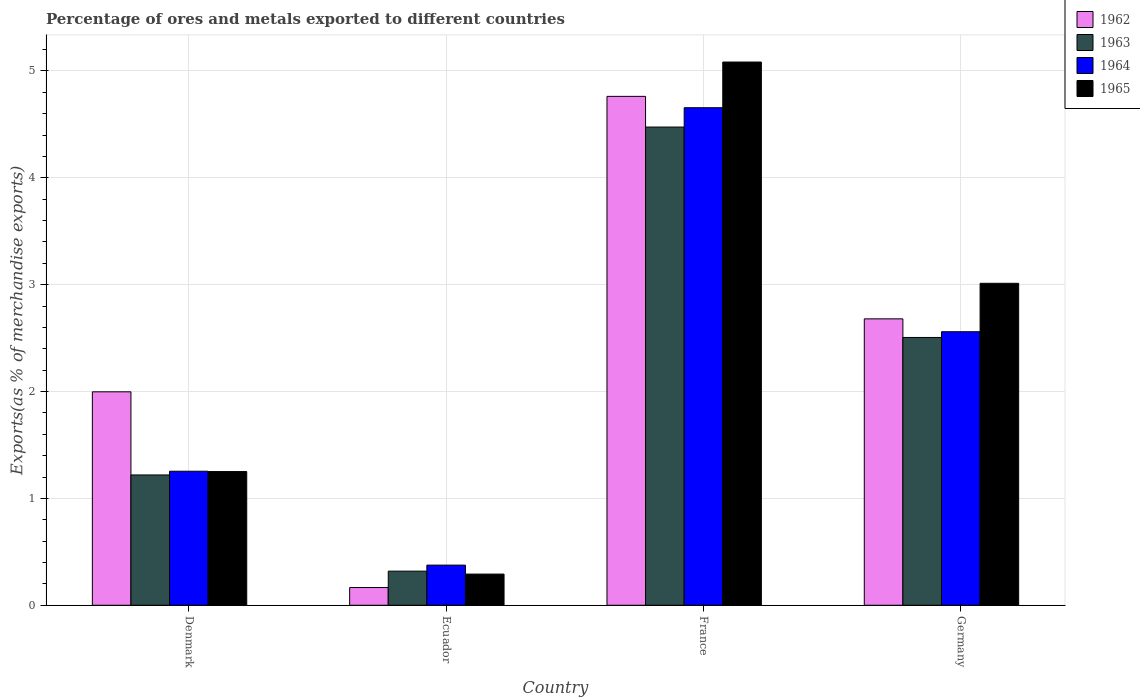Are the number of bars on each tick of the X-axis equal?
Ensure brevity in your answer.  Yes. How many bars are there on the 4th tick from the left?
Offer a very short reply. 4. How many bars are there on the 3rd tick from the right?
Your answer should be compact. 4. What is the label of the 2nd group of bars from the left?
Provide a succinct answer. Ecuador. In how many cases, is the number of bars for a given country not equal to the number of legend labels?
Provide a succinct answer. 0. What is the percentage of exports to different countries in 1963 in Germany?
Your response must be concise. 2.51. Across all countries, what is the maximum percentage of exports to different countries in 1964?
Offer a terse response. 4.66. Across all countries, what is the minimum percentage of exports to different countries in 1962?
Your response must be concise. 0.17. In which country was the percentage of exports to different countries in 1965 minimum?
Offer a terse response. Ecuador. What is the total percentage of exports to different countries in 1965 in the graph?
Offer a terse response. 9.64. What is the difference between the percentage of exports to different countries in 1963 in Denmark and that in Germany?
Your answer should be compact. -1.29. What is the difference between the percentage of exports to different countries in 1965 in Germany and the percentage of exports to different countries in 1963 in France?
Your answer should be very brief. -1.46. What is the average percentage of exports to different countries in 1962 per country?
Your answer should be very brief. 2.4. What is the difference between the percentage of exports to different countries of/in 1963 and percentage of exports to different countries of/in 1964 in Ecuador?
Make the answer very short. -0.06. In how many countries, is the percentage of exports to different countries in 1964 greater than 3.2 %?
Offer a very short reply. 1. What is the ratio of the percentage of exports to different countries in 1965 in Denmark to that in Germany?
Offer a very short reply. 0.42. Is the difference between the percentage of exports to different countries in 1963 in Denmark and Germany greater than the difference between the percentage of exports to different countries in 1964 in Denmark and Germany?
Ensure brevity in your answer.  Yes. What is the difference between the highest and the second highest percentage of exports to different countries in 1962?
Provide a succinct answer. -0.68. What is the difference between the highest and the lowest percentage of exports to different countries in 1963?
Your answer should be compact. 4.16. Is the sum of the percentage of exports to different countries in 1965 in Ecuador and France greater than the maximum percentage of exports to different countries in 1963 across all countries?
Ensure brevity in your answer.  Yes. Is it the case that in every country, the sum of the percentage of exports to different countries in 1963 and percentage of exports to different countries in 1965 is greater than the sum of percentage of exports to different countries in 1964 and percentage of exports to different countries in 1962?
Provide a short and direct response. No. What does the 3rd bar from the left in Germany represents?
Your response must be concise. 1964. What does the 1st bar from the right in France represents?
Your answer should be very brief. 1965. Is it the case that in every country, the sum of the percentage of exports to different countries in 1962 and percentage of exports to different countries in 1965 is greater than the percentage of exports to different countries in 1963?
Give a very brief answer. Yes. Does the graph contain any zero values?
Your response must be concise. No. Does the graph contain grids?
Your response must be concise. Yes. Where does the legend appear in the graph?
Provide a succinct answer. Top right. How many legend labels are there?
Make the answer very short. 4. How are the legend labels stacked?
Ensure brevity in your answer.  Vertical. What is the title of the graph?
Offer a very short reply. Percentage of ores and metals exported to different countries. What is the label or title of the Y-axis?
Your answer should be compact. Exports(as % of merchandise exports). What is the Exports(as % of merchandise exports) of 1962 in Denmark?
Your response must be concise. 2. What is the Exports(as % of merchandise exports) of 1963 in Denmark?
Make the answer very short. 1.22. What is the Exports(as % of merchandise exports) in 1964 in Denmark?
Provide a succinct answer. 1.25. What is the Exports(as % of merchandise exports) of 1965 in Denmark?
Your answer should be very brief. 1.25. What is the Exports(as % of merchandise exports) of 1962 in Ecuador?
Your answer should be compact. 0.17. What is the Exports(as % of merchandise exports) in 1963 in Ecuador?
Your response must be concise. 0.32. What is the Exports(as % of merchandise exports) of 1964 in Ecuador?
Give a very brief answer. 0.38. What is the Exports(as % of merchandise exports) of 1965 in Ecuador?
Your answer should be very brief. 0.29. What is the Exports(as % of merchandise exports) of 1962 in France?
Provide a succinct answer. 4.76. What is the Exports(as % of merchandise exports) in 1963 in France?
Keep it short and to the point. 4.48. What is the Exports(as % of merchandise exports) in 1964 in France?
Your answer should be compact. 4.66. What is the Exports(as % of merchandise exports) of 1965 in France?
Ensure brevity in your answer.  5.08. What is the Exports(as % of merchandise exports) in 1962 in Germany?
Your answer should be very brief. 2.68. What is the Exports(as % of merchandise exports) in 1963 in Germany?
Ensure brevity in your answer.  2.51. What is the Exports(as % of merchandise exports) of 1964 in Germany?
Give a very brief answer. 2.56. What is the Exports(as % of merchandise exports) of 1965 in Germany?
Keep it short and to the point. 3.01. Across all countries, what is the maximum Exports(as % of merchandise exports) in 1962?
Offer a very short reply. 4.76. Across all countries, what is the maximum Exports(as % of merchandise exports) in 1963?
Your answer should be compact. 4.48. Across all countries, what is the maximum Exports(as % of merchandise exports) of 1964?
Your response must be concise. 4.66. Across all countries, what is the maximum Exports(as % of merchandise exports) of 1965?
Give a very brief answer. 5.08. Across all countries, what is the minimum Exports(as % of merchandise exports) in 1962?
Offer a terse response. 0.17. Across all countries, what is the minimum Exports(as % of merchandise exports) of 1963?
Provide a succinct answer. 0.32. Across all countries, what is the minimum Exports(as % of merchandise exports) of 1964?
Keep it short and to the point. 0.38. Across all countries, what is the minimum Exports(as % of merchandise exports) in 1965?
Ensure brevity in your answer.  0.29. What is the total Exports(as % of merchandise exports) of 1962 in the graph?
Make the answer very short. 9.61. What is the total Exports(as % of merchandise exports) in 1963 in the graph?
Ensure brevity in your answer.  8.52. What is the total Exports(as % of merchandise exports) in 1964 in the graph?
Keep it short and to the point. 8.85. What is the total Exports(as % of merchandise exports) in 1965 in the graph?
Your answer should be compact. 9.64. What is the difference between the Exports(as % of merchandise exports) of 1962 in Denmark and that in Ecuador?
Offer a very short reply. 1.83. What is the difference between the Exports(as % of merchandise exports) of 1963 in Denmark and that in Ecuador?
Your answer should be compact. 0.9. What is the difference between the Exports(as % of merchandise exports) of 1964 in Denmark and that in Ecuador?
Your response must be concise. 0.88. What is the difference between the Exports(as % of merchandise exports) in 1965 in Denmark and that in Ecuador?
Give a very brief answer. 0.96. What is the difference between the Exports(as % of merchandise exports) in 1962 in Denmark and that in France?
Make the answer very short. -2.76. What is the difference between the Exports(as % of merchandise exports) of 1963 in Denmark and that in France?
Your answer should be compact. -3.26. What is the difference between the Exports(as % of merchandise exports) in 1964 in Denmark and that in France?
Offer a very short reply. -3.4. What is the difference between the Exports(as % of merchandise exports) in 1965 in Denmark and that in France?
Your answer should be compact. -3.83. What is the difference between the Exports(as % of merchandise exports) of 1962 in Denmark and that in Germany?
Your answer should be compact. -0.68. What is the difference between the Exports(as % of merchandise exports) of 1963 in Denmark and that in Germany?
Provide a succinct answer. -1.29. What is the difference between the Exports(as % of merchandise exports) in 1964 in Denmark and that in Germany?
Your response must be concise. -1.31. What is the difference between the Exports(as % of merchandise exports) in 1965 in Denmark and that in Germany?
Offer a very short reply. -1.76. What is the difference between the Exports(as % of merchandise exports) in 1962 in Ecuador and that in France?
Make the answer very short. -4.6. What is the difference between the Exports(as % of merchandise exports) in 1963 in Ecuador and that in France?
Keep it short and to the point. -4.16. What is the difference between the Exports(as % of merchandise exports) of 1964 in Ecuador and that in France?
Provide a short and direct response. -4.28. What is the difference between the Exports(as % of merchandise exports) of 1965 in Ecuador and that in France?
Provide a succinct answer. -4.79. What is the difference between the Exports(as % of merchandise exports) of 1962 in Ecuador and that in Germany?
Offer a very short reply. -2.51. What is the difference between the Exports(as % of merchandise exports) of 1963 in Ecuador and that in Germany?
Provide a succinct answer. -2.19. What is the difference between the Exports(as % of merchandise exports) in 1964 in Ecuador and that in Germany?
Your answer should be very brief. -2.18. What is the difference between the Exports(as % of merchandise exports) of 1965 in Ecuador and that in Germany?
Offer a very short reply. -2.72. What is the difference between the Exports(as % of merchandise exports) of 1962 in France and that in Germany?
Your answer should be compact. 2.08. What is the difference between the Exports(as % of merchandise exports) in 1963 in France and that in Germany?
Your response must be concise. 1.97. What is the difference between the Exports(as % of merchandise exports) in 1964 in France and that in Germany?
Your response must be concise. 2.1. What is the difference between the Exports(as % of merchandise exports) in 1965 in France and that in Germany?
Your response must be concise. 2.07. What is the difference between the Exports(as % of merchandise exports) in 1962 in Denmark and the Exports(as % of merchandise exports) in 1963 in Ecuador?
Offer a terse response. 1.68. What is the difference between the Exports(as % of merchandise exports) of 1962 in Denmark and the Exports(as % of merchandise exports) of 1964 in Ecuador?
Your response must be concise. 1.62. What is the difference between the Exports(as % of merchandise exports) in 1962 in Denmark and the Exports(as % of merchandise exports) in 1965 in Ecuador?
Your response must be concise. 1.71. What is the difference between the Exports(as % of merchandise exports) of 1963 in Denmark and the Exports(as % of merchandise exports) of 1964 in Ecuador?
Provide a short and direct response. 0.84. What is the difference between the Exports(as % of merchandise exports) of 1963 in Denmark and the Exports(as % of merchandise exports) of 1965 in Ecuador?
Keep it short and to the point. 0.93. What is the difference between the Exports(as % of merchandise exports) in 1964 in Denmark and the Exports(as % of merchandise exports) in 1965 in Ecuador?
Provide a short and direct response. 0.96. What is the difference between the Exports(as % of merchandise exports) in 1962 in Denmark and the Exports(as % of merchandise exports) in 1963 in France?
Keep it short and to the point. -2.48. What is the difference between the Exports(as % of merchandise exports) in 1962 in Denmark and the Exports(as % of merchandise exports) in 1964 in France?
Ensure brevity in your answer.  -2.66. What is the difference between the Exports(as % of merchandise exports) in 1962 in Denmark and the Exports(as % of merchandise exports) in 1965 in France?
Offer a terse response. -3.09. What is the difference between the Exports(as % of merchandise exports) of 1963 in Denmark and the Exports(as % of merchandise exports) of 1964 in France?
Give a very brief answer. -3.44. What is the difference between the Exports(as % of merchandise exports) in 1963 in Denmark and the Exports(as % of merchandise exports) in 1965 in France?
Keep it short and to the point. -3.86. What is the difference between the Exports(as % of merchandise exports) of 1964 in Denmark and the Exports(as % of merchandise exports) of 1965 in France?
Give a very brief answer. -3.83. What is the difference between the Exports(as % of merchandise exports) of 1962 in Denmark and the Exports(as % of merchandise exports) of 1963 in Germany?
Ensure brevity in your answer.  -0.51. What is the difference between the Exports(as % of merchandise exports) of 1962 in Denmark and the Exports(as % of merchandise exports) of 1964 in Germany?
Keep it short and to the point. -0.56. What is the difference between the Exports(as % of merchandise exports) in 1962 in Denmark and the Exports(as % of merchandise exports) in 1965 in Germany?
Provide a succinct answer. -1.02. What is the difference between the Exports(as % of merchandise exports) of 1963 in Denmark and the Exports(as % of merchandise exports) of 1964 in Germany?
Offer a terse response. -1.34. What is the difference between the Exports(as % of merchandise exports) of 1963 in Denmark and the Exports(as % of merchandise exports) of 1965 in Germany?
Offer a terse response. -1.79. What is the difference between the Exports(as % of merchandise exports) of 1964 in Denmark and the Exports(as % of merchandise exports) of 1965 in Germany?
Keep it short and to the point. -1.76. What is the difference between the Exports(as % of merchandise exports) of 1962 in Ecuador and the Exports(as % of merchandise exports) of 1963 in France?
Provide a short and direct response. -4.31. What is the difference between the Exports(as % of merchandise exports) in 1962 in Ecuador and the Exports(as % of merchandise exports) in 1964 in France?
Offer a very short reply. -4.49. What is the difference between the Exports(as % of merchandise exports) of 1962 in Ecuador and the Exports(as % of merchandise exports) of 1965 in France?
Your answer should be very brief. -4.92. What is the difference between the Exports(as % of merchandise exports) of 1963 in Ecuador and the Exports(as % of merchandise exports) of 1964 in France?
Make the answer very short. -4.34. What is the difference between the Exports(as % of merchandise exports) of 1963 in Ecuador and the Exports(as % of merchandise exports) of 1965 in France?
Your response must be concise. -4.76. What is the difference between the Exports(as % of merchandise exports) of 1964 in Ecuador and the Exports(as % of merchandise exports) of 1965 in France?
Give a very brief answer. -4.71. What is the difference between the Exports(as % of merchandise exports) in 1962 in Ecuador and the Exports(as % of merchandise exports) in 1963 in Germany?
Offer a terse response. -2.34. What is the difference between the Exports(as % of merchandise exports) of 1962 in Ecuador and the Exports(as % of merchandise exports) of 1964 in Germany?
Your response must be concise. -2.39. What is the difference between the Exports(as % of merchandise exports) of 1962 in Ecuador and the Exports(as % of merchandise exports) of 1965 in Germany?
Keep it short and to the point. -2.85. What is the difference between the Exports(as % of merchandise exports) in 1963 in Ecuador and the Exports(as % of merchandise exports) in 1964 in Germany?
Offer a very short reply. -2.24. What is the difference between the Exports(as % of merchandise exports) in 1963 in Ecuador and the Exports(as % of merchandise exports) in 1965 in Germany?
Offer a terse response. -2.69. What is the difference between the Exports(as % of merchandise exports) of 1964 in Ecuador and the Exports(as % of merchandise exports) of 1965 in Germany?
Keep it short and to the point. -2.64. What is the difference between the Exports(as % of merchandise exports) in 1962 in France and the Exports(as % of merchandise exports) in 1963 in Germany?
Give a very brief answer. 2.26. What is the difference between the Exports(as % of merchandise exports) of 1962 in France and the Exports(as % of merchandise exports) of 1964 in Germany?
Ensure brevity in your answer.  2.2. What is the difference between the Exports(as % of merchandise exports) of 1962 in France and the Exports(as % of merchandise exports) of 1965 in Germany?
Offer a terse response. 1.75. What is the difference between the Exports(as % of merchandise exports) in 1963 in France and the Exports(as % of merchandise exports) in 1964 in Germany?
Offer a terse response. 1.92. What is the difference between the Exports(as % of merchandise exports) in 1963 in France and the Exports(as % of merchandise exports) in 1965 in Germany?
Your response must be concise. 1.46. What is the difference between the Exports(as % of merchandise exports) of 1964 in France and the Exports(as % of merchandise exports) of 1965 in Germany?
Your answer should be very brief. 1.64. What is the average Exports(as % of merchandise exports) of 1962 per country?
Keep it short and to the point. 2.4. What is the average Exports(as % of merchandise exports) of 1963 per country?
Ensure brevity in your answer.  2.13. What is the average Exports(as % of merchandise exports) in 1964 per country?
Offer a terse response. 2.21. What is the average Exports(as % of merchandise exports) of 1965 per country?
Make the answer very short. 2.41. What is the difference between the Exports(as % of merchandise exports) in 1962 and Exports(as % of merchandise exports) in 1963 in Denmark?
Your answer should be very brief. 0.78. What is the difference between the Exports(as % of merchandise exports) in 1962 and Exports(as % of merchandise exports) in 1964 in Denmark?
Keep it short and to the point. 0.74. What is the difference between the Exports(as % of merchandise exports) in 1962 and Exports(as % of merchandise exports) in 1965 in Denmark?
Ensure brevity in your answer.  0.75. What is the difference between the Exports(as % of merchandise exports) in 1963 and Exports(as % of merchandise exports) in 1964 in Denmark?
Offer a very short reply. -0.03. What is the difference between the Exports(as % of merchandise exports) in 1963 and Exports(as % of merchandise exports) in 1965 in Denmark?
Ensure brevity in your answer.  -0.03. What is the difference between the Exports(as % of merchandise exports) of 1964 and Exports(as % of merchandise exports) of 1965 in Denmark?
Your answer should be compact. 0. What is the difference between the Exports(as % of merchandise exports) of 1962 and Exports(as % of merchandise exports) of 1963 in Ecuador?
Your answer should be very brief. -0.15. What is the difference between the Exports(as % of merchandise exports) of 1962 and Exports(as % of merchandise exports) of 1964 in Ecuador?
Provide a succinct answer. -0.21. What is the difference between the Exports(as % of merchandise exports) in 1962 and Exports(as % of merchandise exports) in 1965 in Ecuador?
Ensure brevity in your answer.  -0.13. What is the difference between the Exports(as % of merchandise exports) in 1963 and Exports(as % of merchandise exports) in 1964 in Ecuador?
Ensure brevity in your answer.  -0.06. What is the difference between the Exports(as % of merchandise exports) of 1963 and Exports(as % of merchandise exports) of 1965 in Ecuador?
Make the answer very short. 0.03. What is the difference between the Exports(as % of merchandise exports) of 1964 and Exports(as % of merchandise exports) of 1965 in Ecuador?
Make the answer very short. 0.08. What is the difference between the Exports(as % of merchandise exports) in 1962 and Exports(as % of merchandise exports) in 1963 in France?
Keep it short and to the point. 0.29. What is the difference between the Exports(as % of merchandise exports) of 1962 and Exports(as % of merchandise exports) of 1964 in France?
Your answer should be very brief. 0.11. What is the difference between the Exports(as % of merchandise exports) in 1962 and Exports(as % of merchandise exports) in 1965 in France?
Offer a very short reply. -0.32. What is the difference between the Exports(as % of merchandise exports) of 1963 and Exports(as % of merchandise exports) of 1964 in France?
Provide a succinct answer. -0.18. What is the difference between the Exports(as % of merchandise exports) of 1963 and Exports(as % of merchandise exports) of 1965 in France?
Provide a short and direct response. -0.61. What is the difference between the Exports(as % of merchandise exports) of 1964 and Exports(as % of merchandise exports) of 1965 in France?
Keep it short and to the point. -0.43. What is the difference between the Exports(as % of merchandise exports) of 1962 and Exports(as % of merchandise exports) of 1963 in Germany?
Give a very brief answer. 0.17. What is the difference between the Exports(as % of merchandise exports) of 1962 and Exports(as % of merchandise exports) of 1964 in Germany?
Your response must be concise. 0.12. What is the difference between the Exports(as % of merchandise exports) of 1962 and Exports(as % of merchandise exports) of 1965 in Germany?
Provide a succinct answer. -0.33. What is the difference between the Exports(as % of merchandise exports) in 1963 and Exports(as % of merchandise exports) in 1964 in Germany?
Make the answer very short. -0.05. What is the difference between the Exports(as % of merchandise exports) of 1963 and Exports(as % of merchandise exports) of 1965 in Germany?
Keep it short and to the point. -0.51. What is the difference between the Exports(as % of merchandise exports) of 1964 and Exports(as % of merchandise exports) of 1965 in Germany?
Offer a terse response. -0.45. What is the ratio of the Exports(as % of merchandise exports) in 1962 in Denmark to that in Ecuador?
Keep it short and to the point. 12.05. What is the ratio of the Exports(as % of merchandise exports) of 1963 in Denmark to that in Ecuador?
Provide a short and direct response. 3.82. What is the ratio of the Exports(as % of merchandise exports) of 1964 in Denmark to that in Ecuador?
Your response must be concise. 3.34. What is the ratio of the Exports(as % of merchandise exports) in 1965 in Denmark to that in Ecuador?
Provide a short and direct response. 4.29. What is the ratio of the Exports(as % of merchandise exports) in 1962 in Denmark to that in France?
Offer a terse response. 0.42. What is the ratio of the Exports(as % of merchandise exports) in 1963 in Denmark to that in France?
Give a very brief answer. 0.27. What is the ratio of the Exports(as % of merchandise exports) of 1964 in Denmark to that in France?
Provide a succinct answer. 0.27. What is the ratio of the Exports(as % of merchandise exports) of 1965 in Denmark to that in France?
Your response must be concise. 0.25. What is the ratio of the Exports(as % of merchandise exports) of 1962 in Denmark to that in Germany?
Give a very brief answer. 0.75. What is the ratio of the Exports(as % of merchandise exports) of 1963 in Denmark to that in Germany?
Your answer should be compact. 0.49. What is the ratio of the Exports(as % of merchandise exports) of 1964 in Denmark to that in Germany?
Your answer should be very brief. 0.49. What is the ratio of the Exports(as % of merchandise exports) in 1965 in Denmark to that in Germany?
Provide a short and direct response. 0.42. What is the ratio of the Exports(as % of merchandise exports) in 1962 in Ecuador to that in France?
Give a very brief answer. 0.03. What is the ratio of the Exports(as % of merchandise exports) of 1963 in Ecuador to that in France?
Provide a succinct answer. 0.07. What is the ratio of the Exports(as % of merchandise exports) of 1964 in Ecuador to that in France?
Your response must be concise. 0.08. What is the ratio of the Exports(as % of merchandise exports) of 1965 in Ecuador to that in France?
Keep it short and to the point. 0.06. What is the ratio of the Exports(as % of merchandise exports) in 1962 in Ecuador to that in Germany?
Offer a terse response. 0.06. What is the ratio of the Exports(as % of merchandise exports) in 1963 in Ecuador to that in Germany?
Provide a short and direct response. 0.13. What is the ratio of the Exports(as % of merchandise exports) of 1964 in Ecuador to that in Germany?
Your answer should be compact. 0.15. What is the ratio of the Exports(as % of merchandise exports) in 1965 in Ecuador to that in Germany?
Make the answer very short. 0.1. What is the ratio of the Exports(as % of merchandise exports) of 1962 in France to that in Germany?
Give a very brief answer. 1.78. What is the ratio of the Exports(as % of merchandise exports) of 1963 in France to that in Germany?
Keep it short and to the point. 1.79. What is the ratio of the Exports(as % of merchandise exports) in 1964 in France to that in Germany?
Your answer should be very brief. 1.82. What is the ratio of the Exports(as % of merchandise exports) in 1965 in France to that in Germany?
Make the answer very short. 1.69. What is the difference between the highest and the second highest Exports(as % of merchandise exports) in 1962?
Make the answer very short. 2.08. What is the difference between the highest and the second highest Exports(as % of merchandise exports) of 1963?
Ensure brevity in your answer.  1.97. What is the difference between the highest and the second highest Exports(as % of merchandise exports) in 1964?
Provide a short and direct response. 2.1. What is the difference between the highest and the second highest Exports(as % of merchandise exports) of 1965?
Your answer should be very brief. 2.07. What is the difference between the highest and the lowest Exports(as % of merchandise exports) in 1962?
Your response must be concise. 4.6. What is the difference between the highest and the lowest Exports(as % of merchandise exports) in 1963?
Provide a succinct answer. 4.16. What is the difference between the highest and the lowest Exports(as % of merchandise exports) of 1964?
Ensure brevity in your answer.  4.28. What is the difference between the highest and the lowest Exports(as % of merchandise exports) in 1965?
Your answer should be compact. 4.79. 